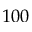<formula> <loc_0><loc_0><loc_500><loc_500>1 0 0</formula> 